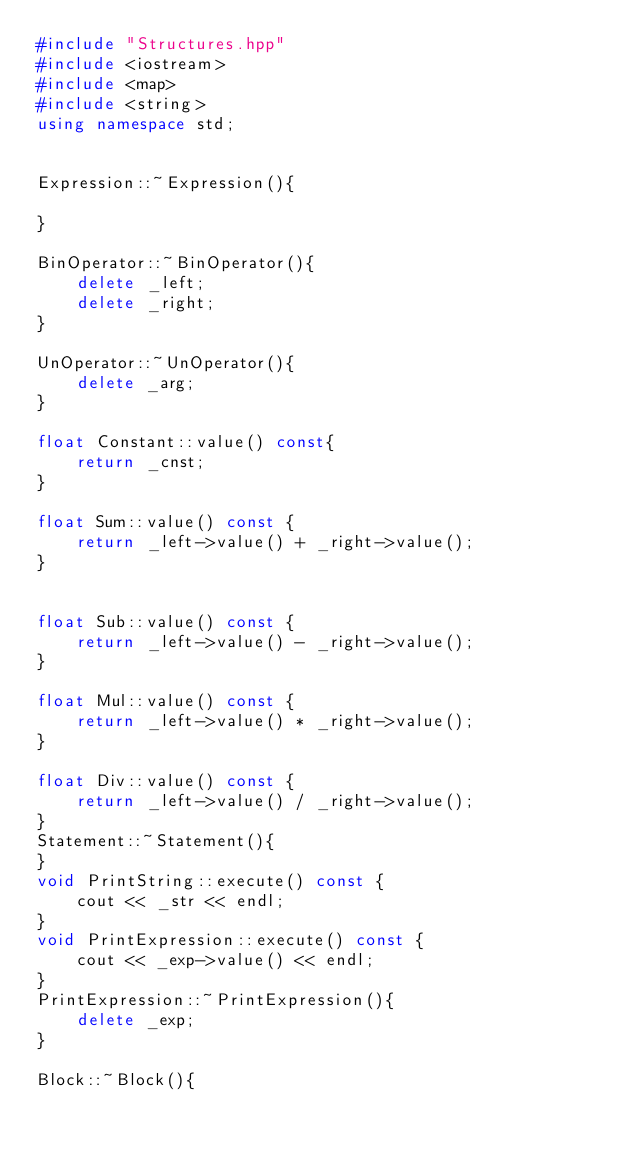<code> <loc_0><loc_0><loc_500><loc_500><_C++_>#include "Structures.hpp"
#include <iostream>
#include <map>
#include <string>
using namespace std;


Expression::~Expression(){
    
}

BinOperator::~BinOperator(){
    delete _left;
    delete _right;
}

UnOperator::~UnOperator(){
    delete _arg;
}

float Constant::value() const{
    return _cnst;
}

float Sum::value() const {
    return _left->value() + _right->value();
}


float Sub::value() const {
    return _left->value() - _right->value();
}

float Mul::value() const {
    return _left->value() * _right->value();
}

float Div::value() const {
    return _left->value() / _right->value();
}
Statement::~Statement(){
}
void PrintString::execute() const {
    cout << _str << endl;
}
void PrintExpression::execute() const {
    cout << _exp->value() << endl;
}
PrintExpression::~PrintExpression(){
    delete _exp;
}

Block::~Block(){</code> 